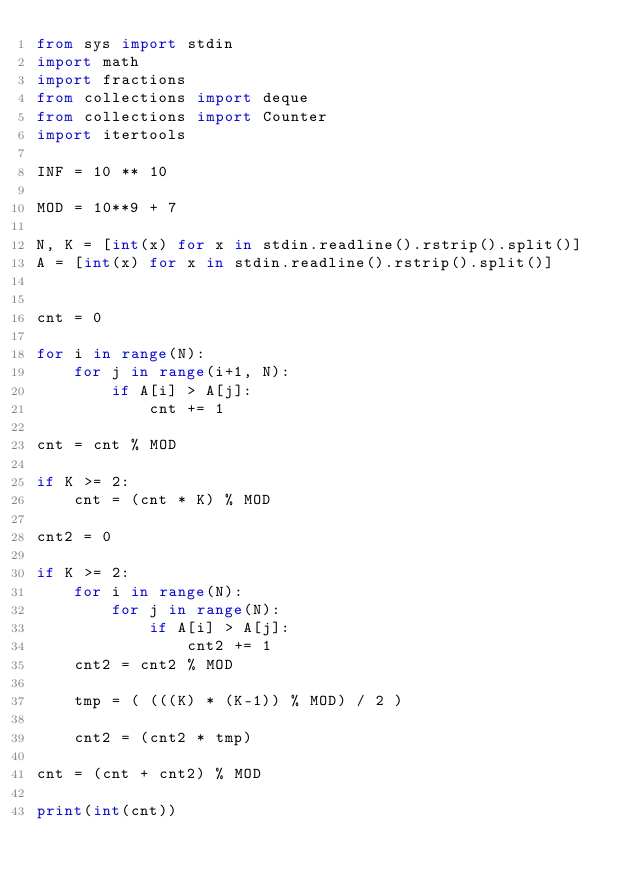Convert code to text. <code><loc_0><loc_0><loc_500><loc_500><_Python_>from sys import stdin
import math
import fractions
from collections import deque
from collections import Counter
import itertools

INF = 10 ** 10

MOD = 10**9 + 7

N, K = [int(x) for x in stdin.readline().rstrip().split()]
A = [int(x) for x in stdin.readline().rstrip().split()]


cnt = 0

for i in range(N):
    for j in range(i+1, N):
        if A[i] > A[j]:
            cnt += 1

cnt = cnt % MOD

if K >= 2:
    cnt = (cnt * K) % MOD

cnt2 = 0

if K >= 2:
    for i in range(N):
        for j in range(N):
            if A[i] > A[j]:
                cnt2 += 1
    cnt2 = cnt2 % MOD

    tmp = ( (((K) * (K-1)) % MOD) / 2 )

    cnt2 = (cnt2 * tmp)

cnt = (cnt + cnt2) % MOD

print(int(cnt))</code> 